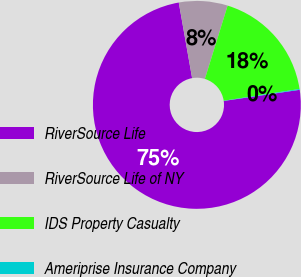Convert chart to OTSL. <chart><loc_0><loc_0><loc_500><loc_500><pie_chart><fcel>RiverSource Life<fcel>RiverSource Life of NY<fcel>IDS Property Casualty<fcel>Ameriprise Insurance Company<nl><fcel>74.53%<fcel>7.57%<fcel>17.77%<fcel>0.13%<nl></chart> 